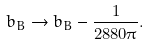Convert formula to latex. <formula><loc_0><loc_0><loc_500><loc_500>b _ { B } \rightarrow b _ { B } - \frac { 1 } { 2 8 8 0 \pi } .</formula> 